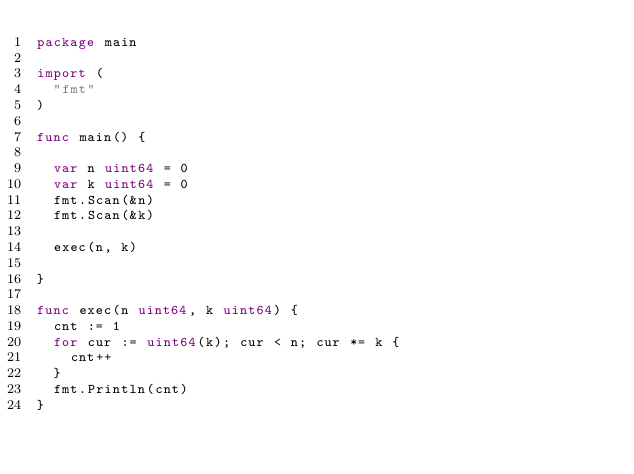Convert code to text. <code><loc_0><loc_0><loc_500><loc_500><_Go_>package main

import (
	"fmt"
)

func main() {

	var n uint64 = 0
	var k uint64 = 0
	fmt.Scan(&n)
	fmt.Scan(&k)

	exec(n, k)

}

func exec(n uint64, k uint64) {
	cnt := 1
	for cur := uint64(k); cur < n; cur *= k {
		cnt++
	}
	fmt.Println(cnt)
}
</code> 